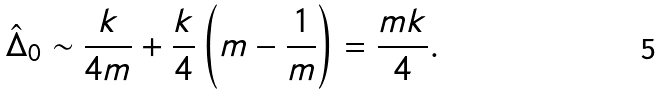Convert formula to latex. <formula><loc_0><loc_0><loc_500><loc_500>\hat { \Delta } _ { 0 } \sim \frac { k } { 4 m } + \frac { k } { 4 } \left ( m - \frac { 1 } { m } \right ) = \frac { m k } { 4 } .</formula> 